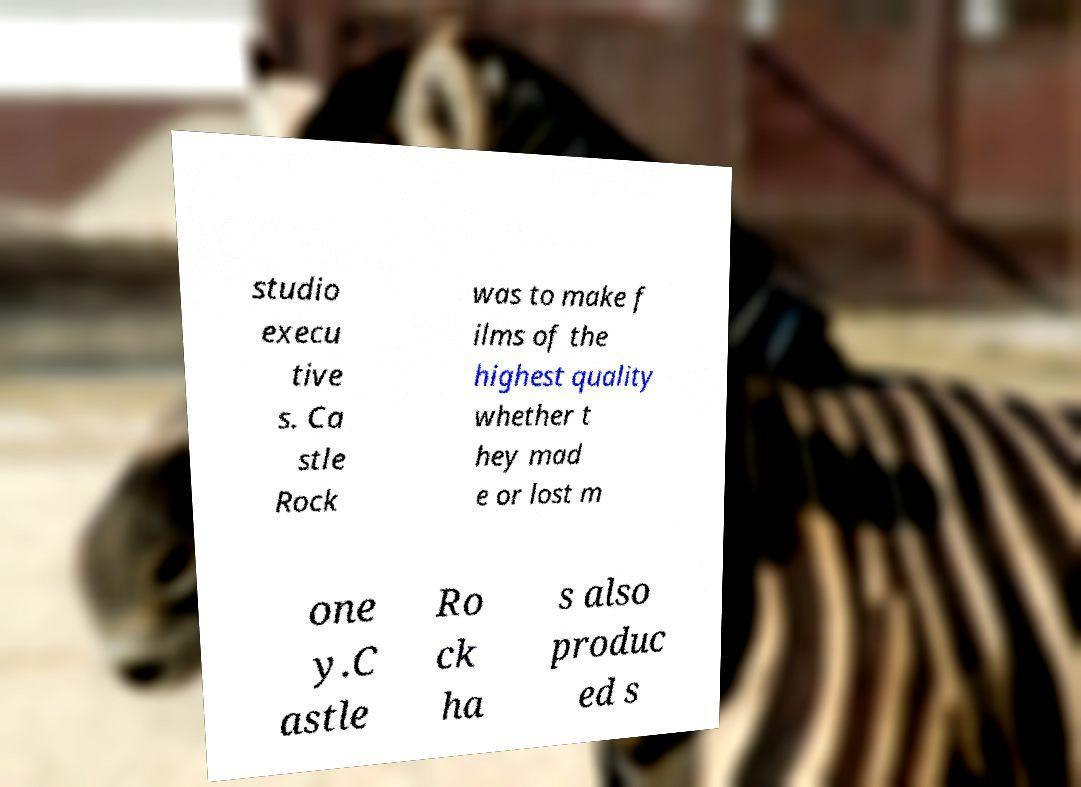What messages or text are displayed in this image? I need them in a readable, typed format. studio execu tive s. Ca stle Rock was to make f ilms of the highest quality whether t hey mad e or lost m one y.C astle Ro ck ha s also produc ed s 